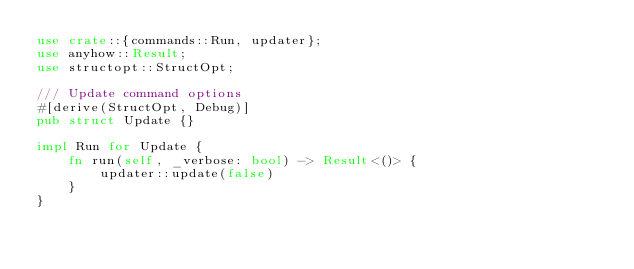<code> <loc_0><loc_0><loc_500><loc_500><_Rust_>use crate::{commands::Run, updater};
use anyhow::Result;
use structopt::StructOpt;

/// Update command options
#[derive(StructOpt, Debug)]
pub struct Update {}

impl Run for Update {
    fn run(self, _verbose: bool) -> Result<()> {
        updater::update(false)
    }
}
</code> 